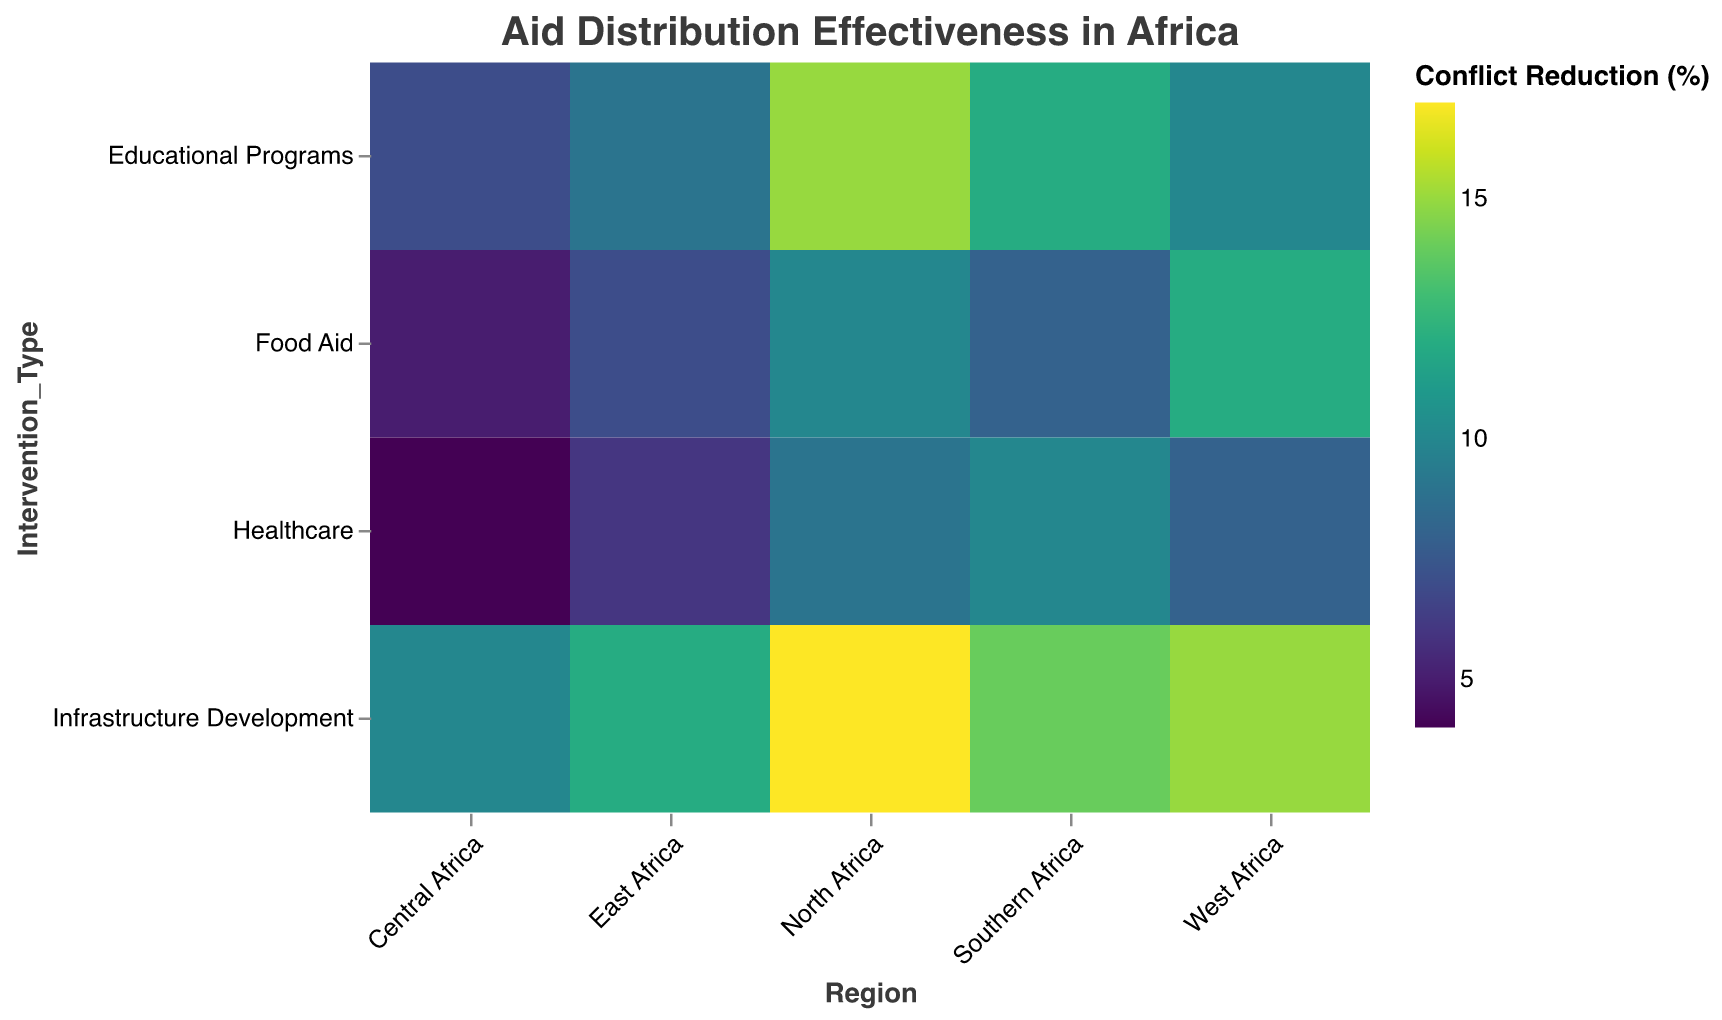What is the aid distribution effectiveness in terms of conflict reduction in North Africa for Educational Programs? The heatmap shows conflict reduction percentages by region and intervention type. For North Africa and Educational Programs, the conflict reduction percentage is highlighted.
Answer: 15% Which region shows the highest conflict reduction percentage for Infrastructure Development? Examining the heatmap across all regions for Infrastructure Development, the highest percentage of conflict reduction can be identified.
Answer: North Africa Compare the conflict reduction percentages between Food Aid and Infrastructure Development in West Africa. In the heatmap, locate the conflict reduction percentages for Food Aid and Infrastructure Development within the West Africa row.
Answer: 12% and 15% What is the average conflict reduction percentage for Healthcare in all regions? Sum the conflict reduction percentages for Healthcare in West Africa, East Africa, Central Africa, Southern Africa, and North Africa, then divide by the number of regions. (8 + 6 + 4 + 10 + 9) / 5 = 7.4
Answer: 7.4% Which region has the lowest conflict reduction percentage for Food Aid? Identify the conflict reduction percentages for all regions under Food Aid and find the lowest value.
Answer: Central Africa What is the total aid amount given to Food Aid across all regions? Sum the aid amounts for Food Aid in West Africa, East Africa, Central Africa, Southern Africa, and North Africa. (2500000 + 2300000 + 2700000 + 2200000 + 2400000) = 12100000
Answer: 12,100,000 USD How does the conflict reduction percentage for Healthcare compare between East Africa and Southern Africa? Find the conflict reduction percentages for Healthcare in East Africa and Southern Africa and compare them.
Answer: 6% and 10% What is the most effective intervention type in terms of conflict reduction in Southern Africa? Examine the conflict reduction percentages for all intervention types in Southern Africa and identify the highest value.
Answer: Infrastructure Development Which intervention type generally shows the highest conflict reduction across all regions? Compare the highest conflict reduction percentages for each intervention type across all regions and identify the intervention type with the highest general performance.
Answer: Infrastructure Development What is the difference in conflict reduction percentages for Educational Programs between North Africa and Central Africa? Subtract the conflict reduction percentage for Educational Programs in Central Africa from that in North Africa. 15 - 7 = 8
Answer: 8% 